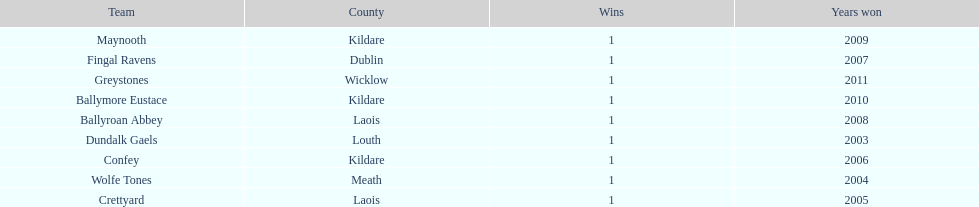How many wins did confey have? 1. 